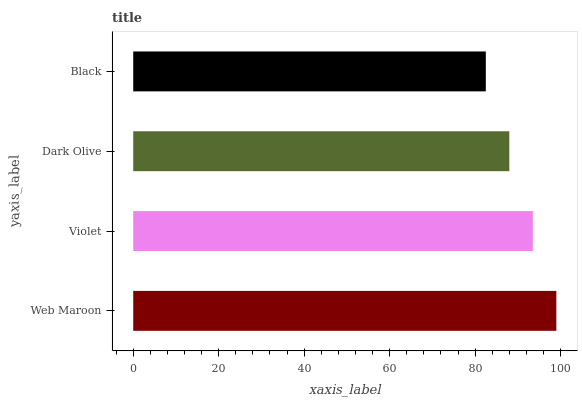Is Black the minimum?
Answer yes or no. Yes. Is Web Maroon the maximum?
Answer yes or no. Yes. Is Violet the minimum?
Answer yes or no. No. Is Violet the maximum?
Answer yes or no. No. Is Web Maroon greater than Violet?
Answer yes or no. Yes. Is Violet less than Web Maroon?
Answer yes or no. Yes. Is Violet greater than Web Maroon?
Answer yes or no. No. Is Web Maroon less than Violet?
Answer yes or no. No. Is Violet the high median?
Answer yes or no. Yes. Is Dark Olive the low median?
Answer yes or no. Yes. Is Black the high median?
Answer yes or no. No. Is Web Maroon the low median?
Answer yes or no. No. 